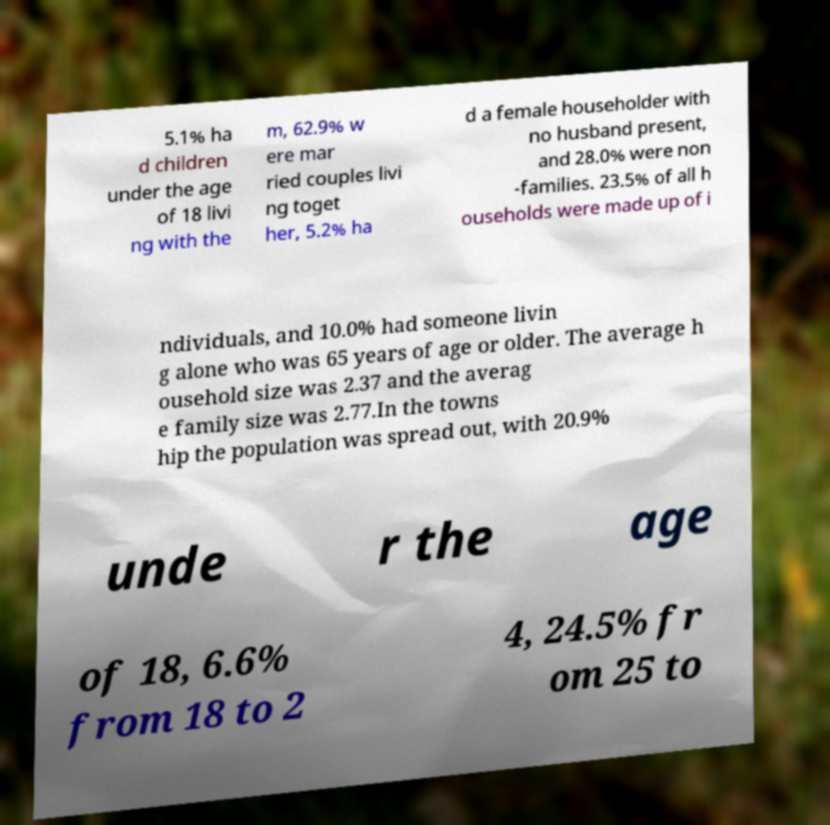Can you accurately transcribe the text from the provided image for me? 5.1% ha d children under the age of 18 livi ng with the m, 62.9% w ere mar ried couples livi ng toget her, 5.2% ha d a female householder with no husband present, and 28.0% were non -families. 23.5% of all h ouseholds were made up of i ndividuals, and 10.0% had someone livin g alone who was 65 years of age or older. The average h ousehold size was 2.37 and the averag e family size was 2.77.In the towns hip the population was spread out, with 20.9% unde r the age of 18, 6.6% from 18 to 2 4, 24.5% fr om 25 to 